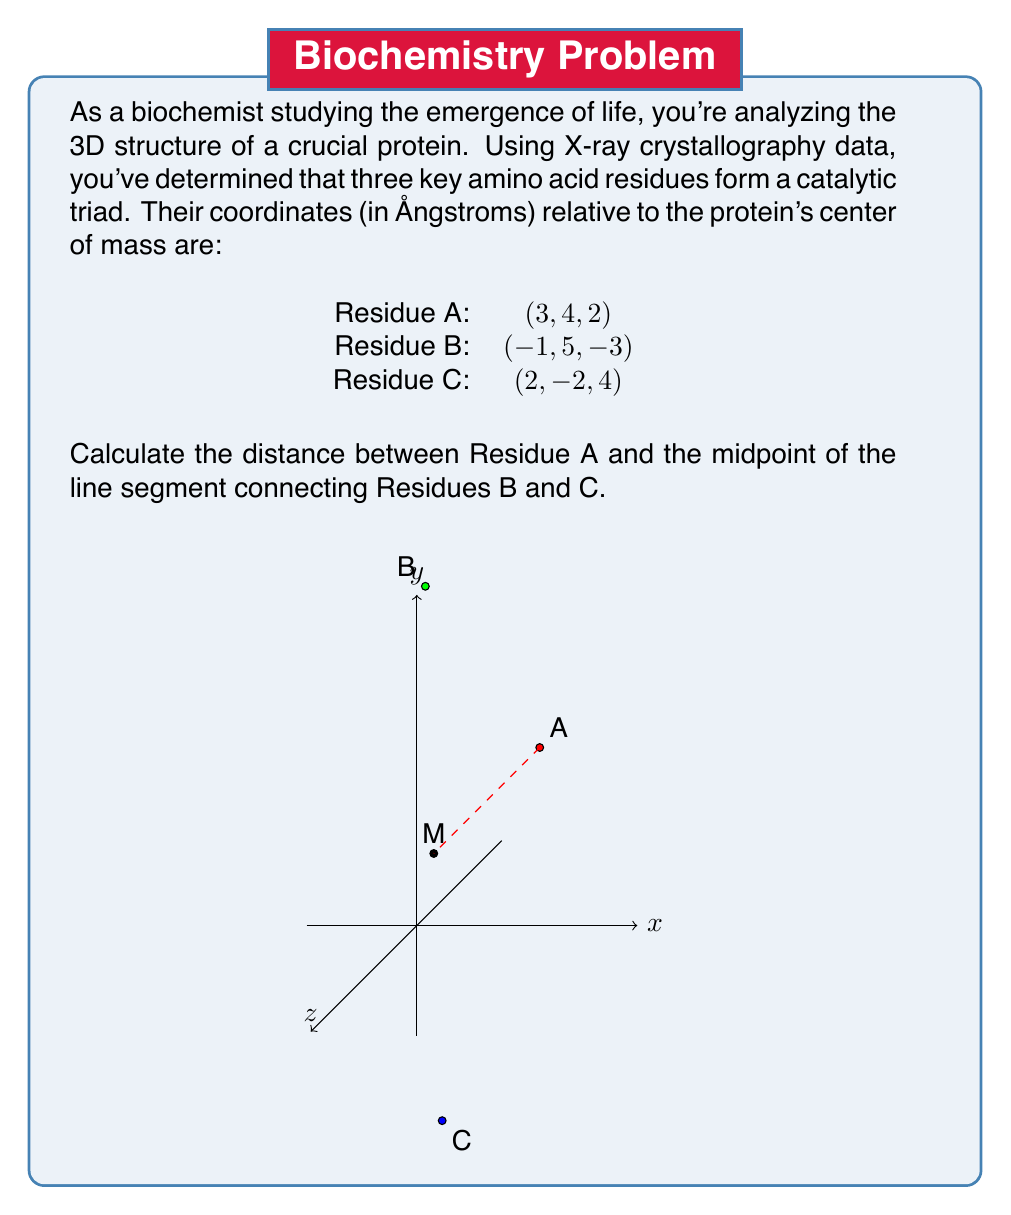Provide a solution to this math problem. Let's approach this step-by-step:

1) First, we need to find the midpoint (M) between Residues B and C. The midpoint formula in 3D is:

   $$M = (\frac{x_1 + x_2}{2}, \frac{y_1 + y_2}{2}, \frac{z_1 + z_2}{2})$$

   Where $(x_1, y_1, z_1)$ are the coordinates of B and $(x_2, y_2, z_2)$ are the coordinates of C.

2) Plugging in the values:

   $$M = (\frac{-1 + 2}{2}, \frac{5 + (-2)}{2}, \frac{-3 + 4}{2}) = (0.5, 1.5, 0.5)$$

3) Now we need to calculate the distance between A (3, 4, 2) and M (0.5, 1.5, 0.5).

4) The distance formula in 3D space is:

   $$d = \sqrt{(x_2 - x_1)^2 + (y_2 - y_1)^2 + (z_2 - z_1)^2}$$

   Where $(x_1, y_1, z_1)$ are the coordinates of A and $(x_2, y_2, z_2)$ are the coordinates of M.

5) Plugging in the values:

   $$d = \sqrt{(0.5 - 3)^2 + (1.5 - 4)^2 + (0.5 - 2)^2}$$

6) Simplifying:

   $$d = \sqrt{(-2.5)^2 + (-2.5)^2 + (-1.5)^2}$$
   $$d = \sqrt{6.25 + 6.25 + 2.25}$$
   $$d = \sqrt{14.75}$$

7) Calculating the final value:

   $$d \approx 3.84 \text{ Å}$$
Answer: $3.84 \text{ Å}$ 